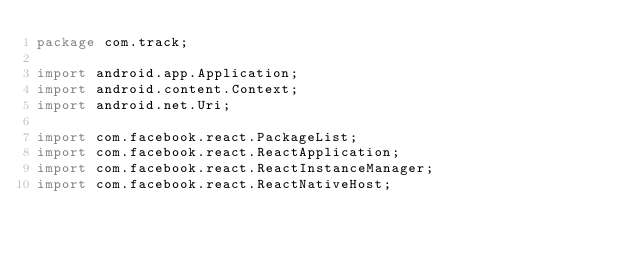Convert code to text. <code><loc_0><loc_0><loc_500><loc_500><_Java_>package com.track;

import android.app.Application;
import android.content.Context;
import android.net.Uri;

import com.facebook.react.PackageList;
import com.facebook.react.ReactApplication;
import com.facebook.react.ReactInstanceManager;
import com.facebook.react.ReactNativeHost;</code> 